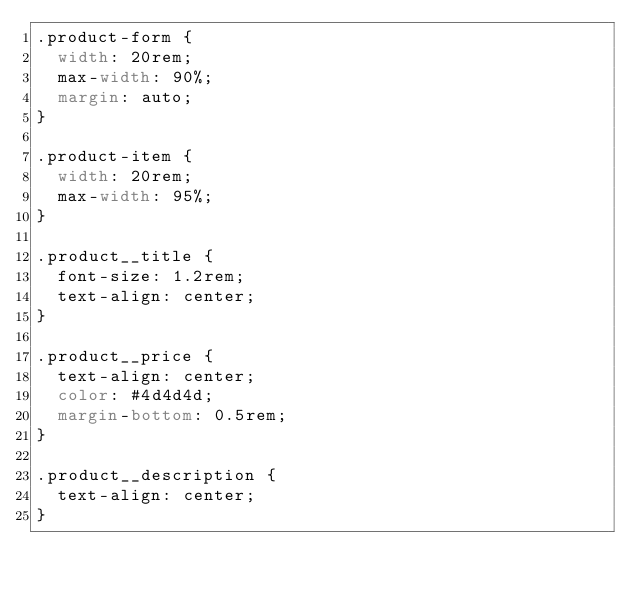Convert code to text. <code><loc_0><loc_0><loc_500><loc_500><_CSS_>.product-form {
  width: 20rem;
  max-width: 90%;
  margin: auto;
}

.product-item {
  width: 20rem;
  max-width: 95%;
}

.product__title {
  font-size: 1.2rem;
  text-align: center;
}

.product__price {
  text-align: center;
  color: #4d4d4d;
  margin-bottom: 0.5rem;
}

.product__description {
  text-align: center;
}</code> 